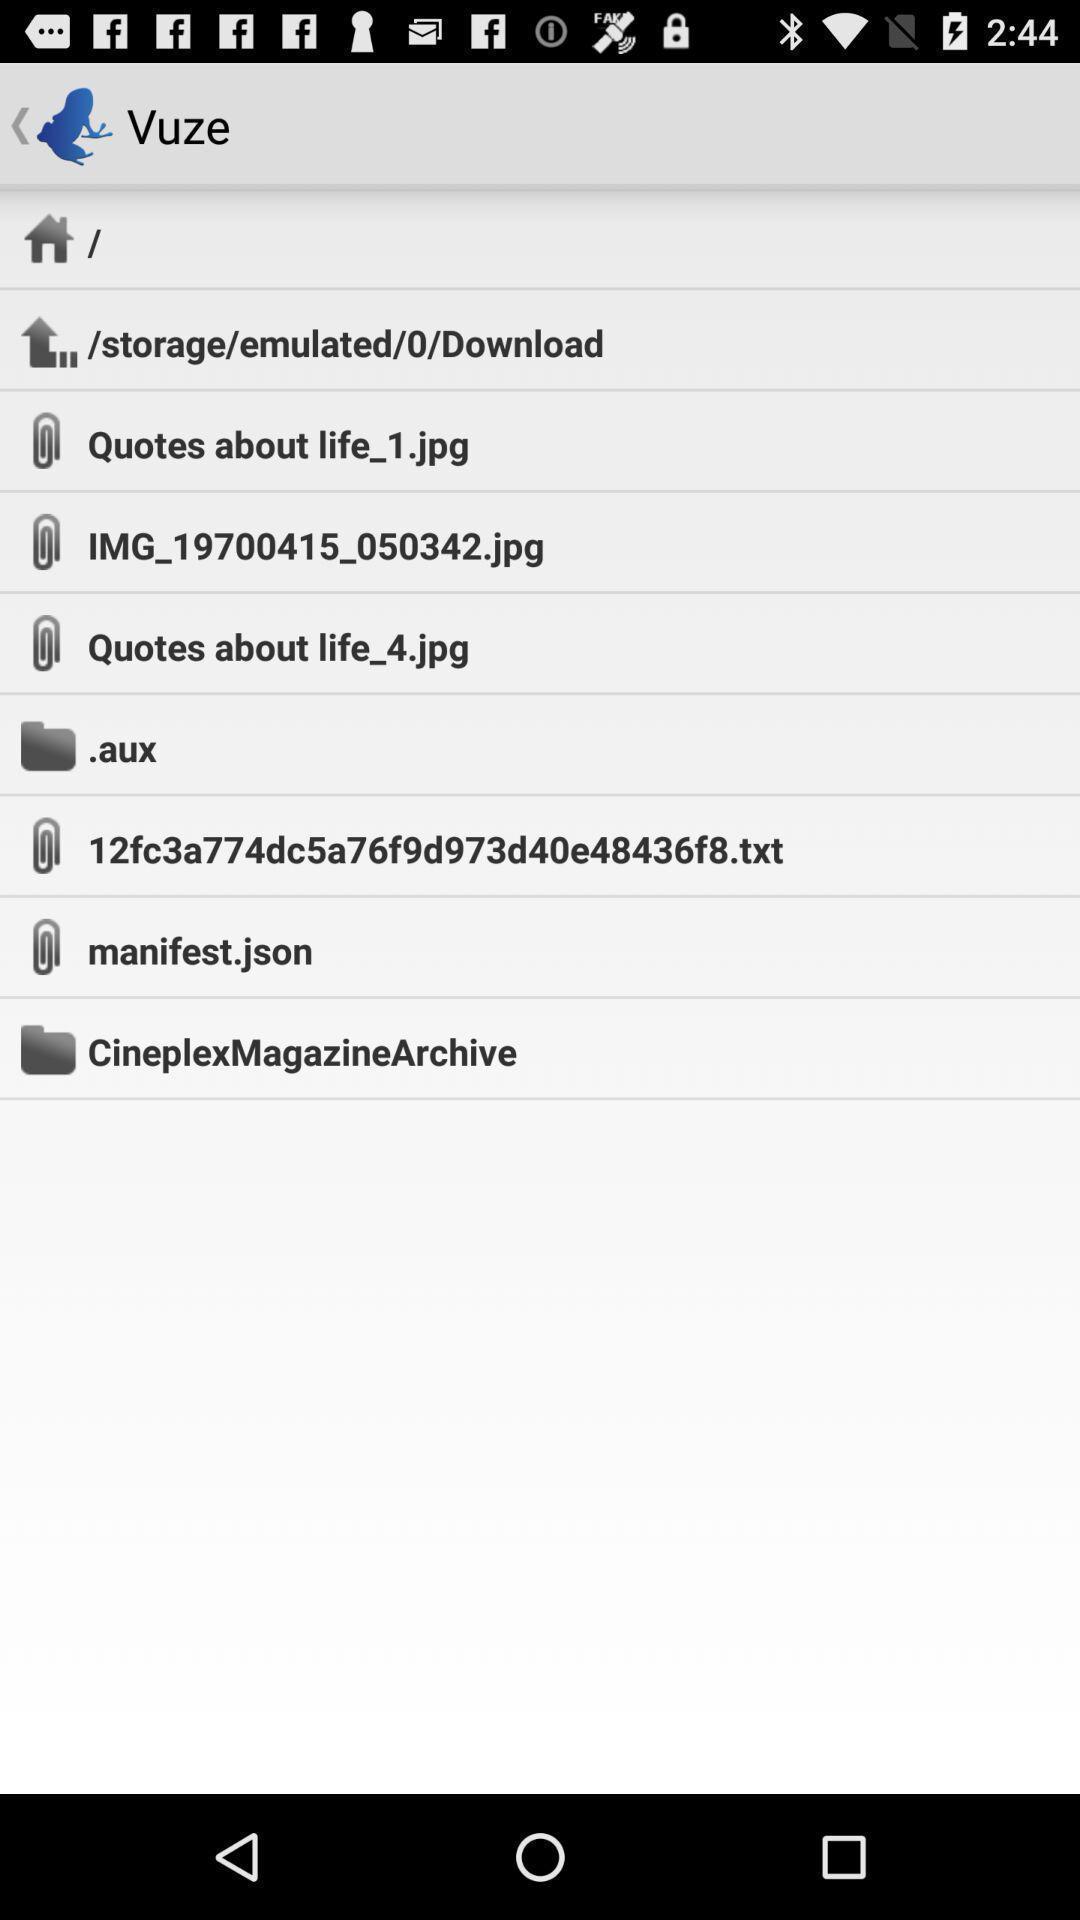Give me a narrative description of this picture. Screen displaying multiple folders and link names in home page. 